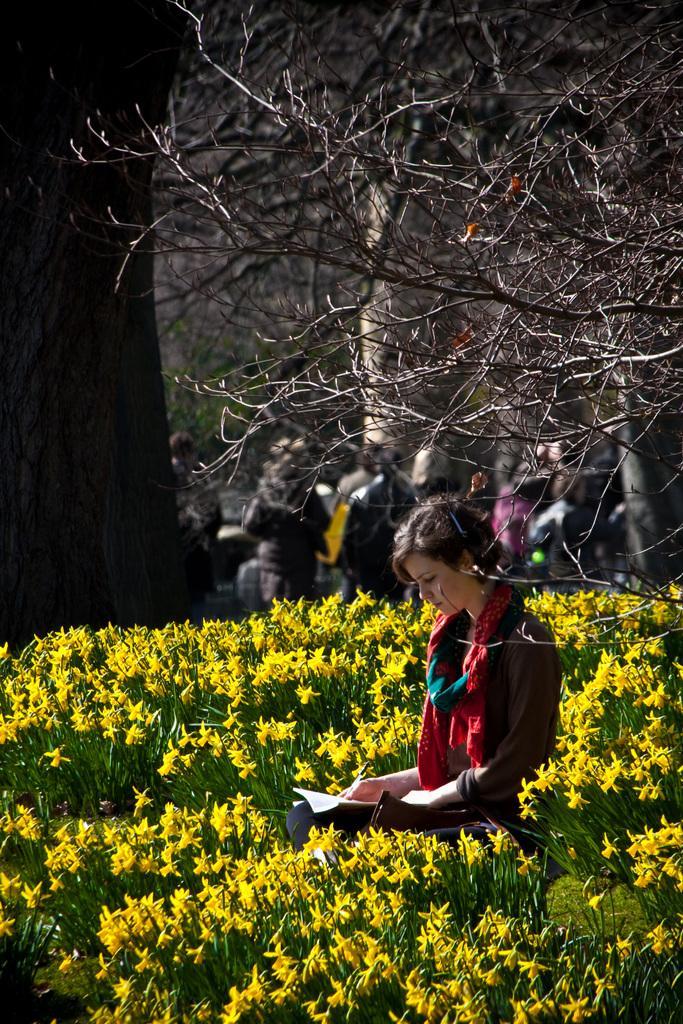Can you describe this image briefly? In this image we can see a woman sitting in between the plants which has some flowers and she is holding the book, behind there are some people and some trees. 